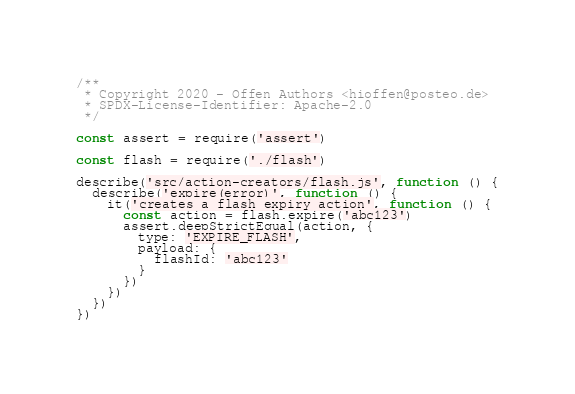Convert code to text. <code><loc_0><loc_0><loc_500><loc_500><_JavaScript_>/**
 * Copyright 2020 - Offen Authors <hioffen@posteo.de>
 * SPDX-License-Identifier: Apache-2.0
 */

const assert = require('assert')

const flash = require('./flash')

describe('src/action-creators/flash.js', function () {
  describe('expire(error)', function () {
    it('creates a flash expiry action', function () {
      const action = flash.expire('abc123')
      assert.deepStrictEqual(action, {
        type: 'EXPIRE_FLASH',
        payload: {
          flashId: 'abc123'
        }
      })
    })
  })
})
</code> 